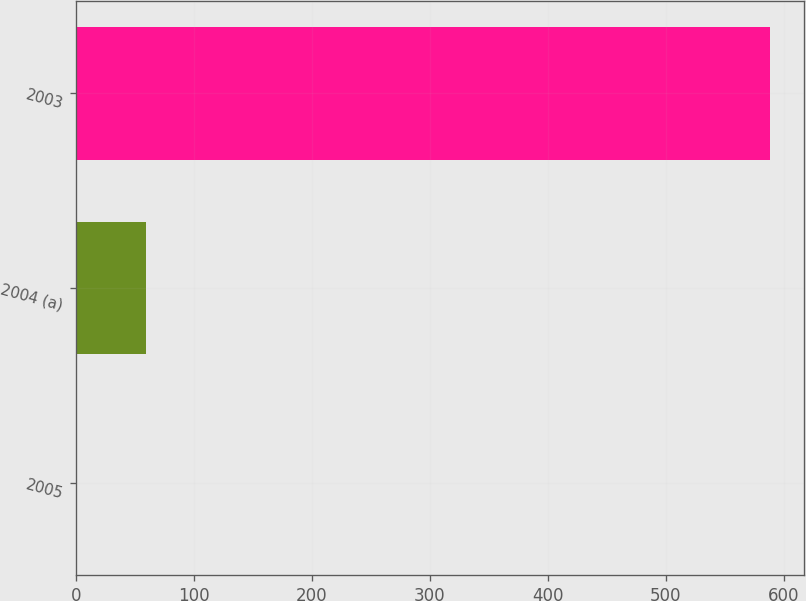Convert chart. <chart><loc_0><loc_0><loc_500><loc_500><bar_chart><fcel>2005<fcel>2004 (a)<fcel>2003<nl><fcel>1<fcel>59.7<fcel>588<nl></chart> 